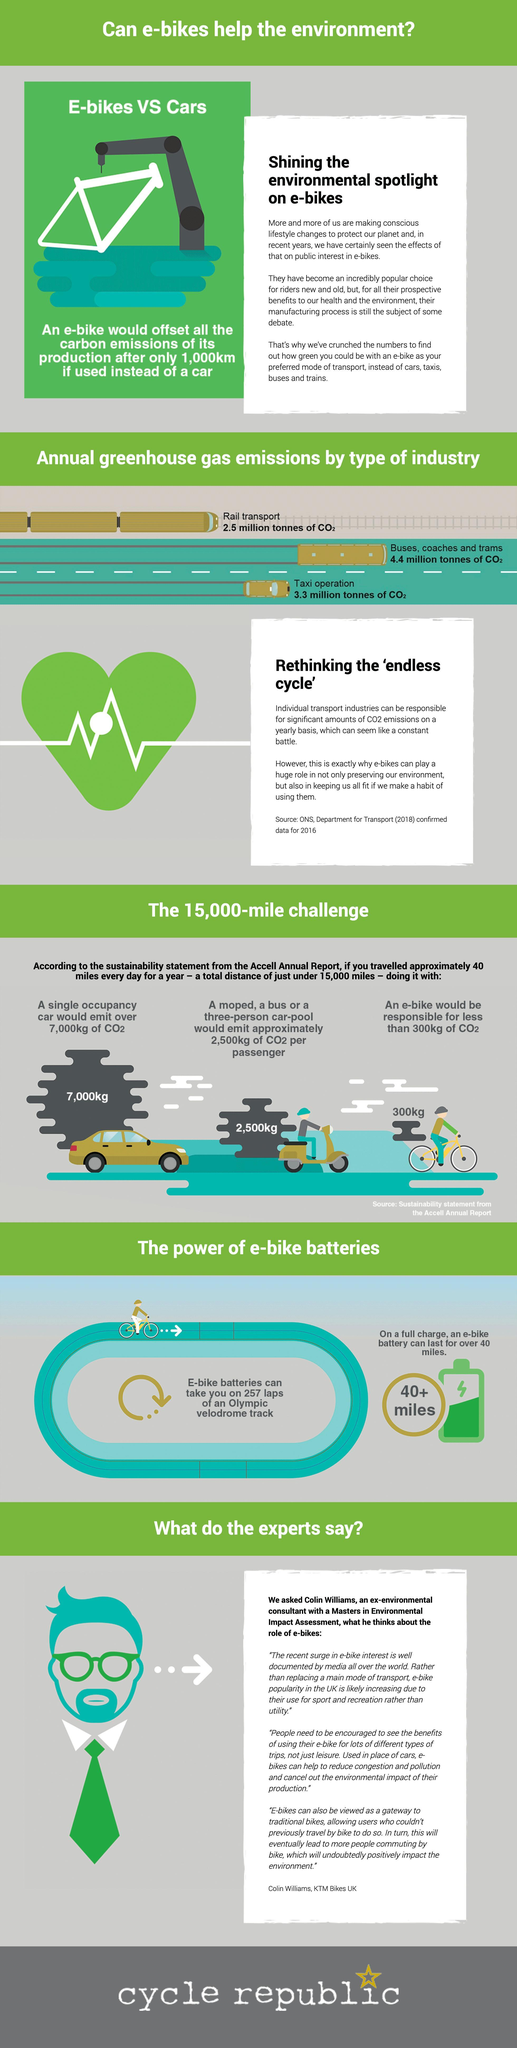Over how many miles would a half charge e-bike battery last
Answer the question with a short phrase. 20 How much more in kg would be the emission of a single occupancy car emission of CO2 when compared to an e-bike 6700 What is the total green house gas emission in million tonnes of CO2 by rail transport and taxi operation 5.8 What is the colour of the spectacles of the expert, green or blue green What is the total green house gas emission in million tonnes of CO2 by buses, coaches and trams and taxi operation 7.7 What would emit 2,500kg of CO2 per passenger A moped, a bus or a three-person car-pool 